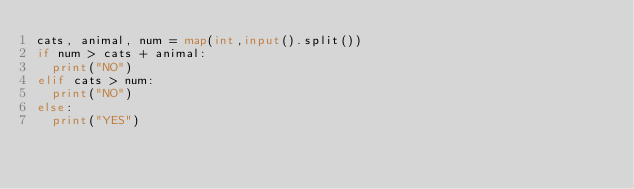<code> <loc_0><loc_0><loc_500><loc_500><_Python_>cats, animal, num = map(int,input().split())
if num > cats + animal:
  print("NO")
elif cats > num:
  print("NO")
else:
  print("YES")</code> 